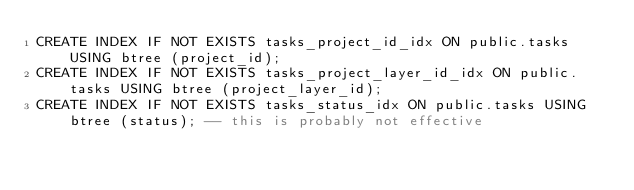Convert code to text. <code><loc_0><loc_0><loc_500><loc_500><_SQL_>CREATE INDEX IF NOT EXISTS tasks_project_id_idx ON public.tasks USING btree (project_id);
CREATE INDEX IF NOT EXISTS tasks_project_layer_id_idx ON public.tasks USING btree (project_layer_id);
CREATE INDEX IF NOT EXISTS tasks_status_idx ON public.tasks USING btree (status); -- this is probably not effective
</code> 